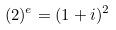Convert formula to latex. <formula><loc_0><loc_0><loc_500><loc_500>( 2 ) ^ { e } = ( 1 + i ) ^ { 2 }</formula> 